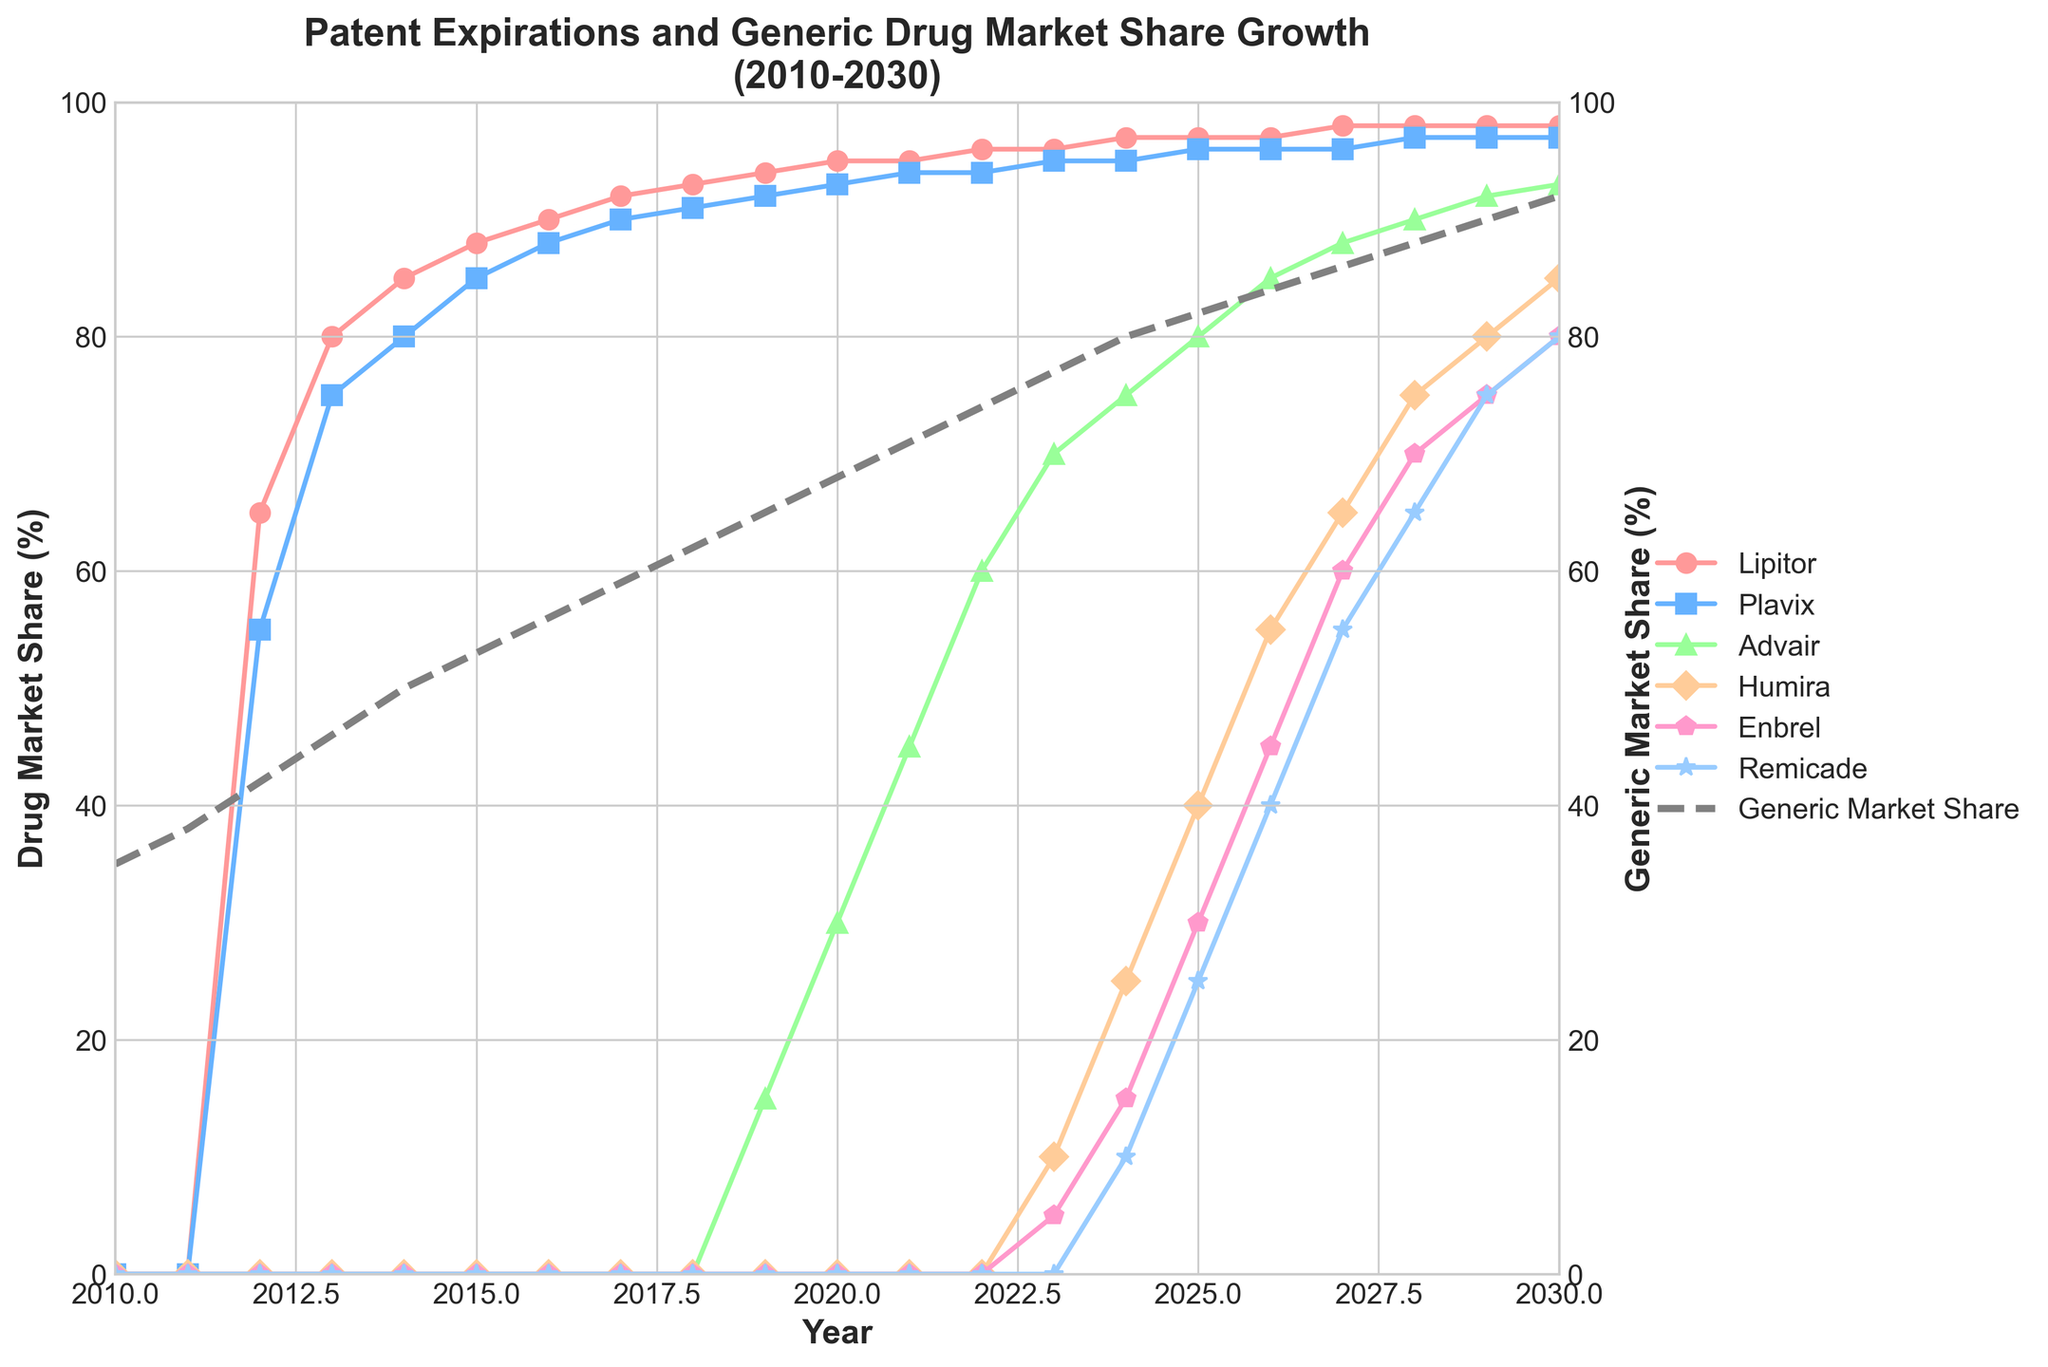What year did Lipitor first show significant market share, and what was it? Lipitor first shows a market share in 2012. To find the value, look at the year 2012 on the x-axis and see the point where the line for Lipitor starts, which is at 65%.
Answer: 2012, 65% Which drug's market share reaches 85% the earliest, and in what year? To determine which drug reaches 85% market share the earliest, look at the lines for each drug and identify when they first touch or exceed 85% on the y-axis. Lipitor reaches 85% in the year 2014.
Answer: Lipitor, 2014 How does the generic market share change from 2010 to 2020? To find the change in generic market share, compare its value in 2010 and 2020. In 2010 it is 35%, and in 2020 it is 68%. Subtract the earlier value from the later value: 68% - 35% = 33%.
Answer: It increases by 33% By how much does Humira's market share grow between 2023 and 2030? Find Humira’s market share in 2023, which is 10%, and in 2030, which is 85%. Subtract the 2023 value from the 2030 value to find the growth: 85% - 10% = 75%.
Answer: It grows by 75% Which drug has the highest market share in 2025, and what is that share? Look at the year 2025 and find the highest point among all the drugs. Lipitor has the highest market share at this point with 97%.
Answer: Lipitor, 97% How does the market share of Enbrel in 2029 compare to that of Remicade in the same year? Find the market share of Enbrel and Remicade in 2029. Enbrel is at 75% and Remicade is also at 75%. Therefore, they are equal.
Answer: They are equal, 75% What is the trend of the generic market share from 2010 to 2030? Observe the line for the generic market share from 2010 to 2030. It consistently increases each year, showing an upward trend.
Answer: It has an upward trend Which drug shows the most delayed market share growth and when does it start to significantly increase? Find the drug whose market share remains at 0% for the longest time before starting to increase. Humira starts to show significant growth in 2023.
Answer: Humira, 2023 What's the difference in market share between Plavix and Advair in 2024? Find Plavix's market share in 2024, which is 95%, and Advair's, which is 75%. Subtract Advair’s share from Plavix’s: 95% - 75% = 20%.
Answer: 20% Compare the market shares of Advair and Humira in 2028. Which one is higher, and by how much? In 2028, look at the values on the y-axis for both Advair and Humira. Advair is at 90% and Humira is at 75%. Subtract Humira's share from Advair's: 90% - 75% = 15%. Advair is higher.
Answer: Advair by 15% 